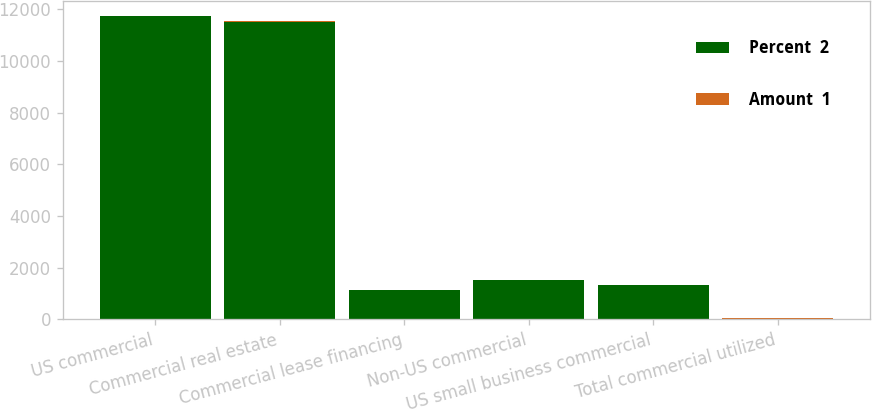<chart> <loc_0><loc_0><loc_500><loc_500><stacked_bar_chart><ecel><fcel>US commercial<fcel>Commercial real estate<fcel>Commercial lease financing<fcel>Non-US commercial<fcel>US small business commercial<fcel>Total commercial utilized<nl><fcel>Percent  2<fcel>11731<fcel>11525<fcel>1140<fcel>1524<fcel>1327<fcel>27.13<nl><fcel>Amount  1<fcel>5.16<fcel>27.13<fcel>5.18<fcel>2.44<fcel>10.01<fcel>7.41<nl></chart> 